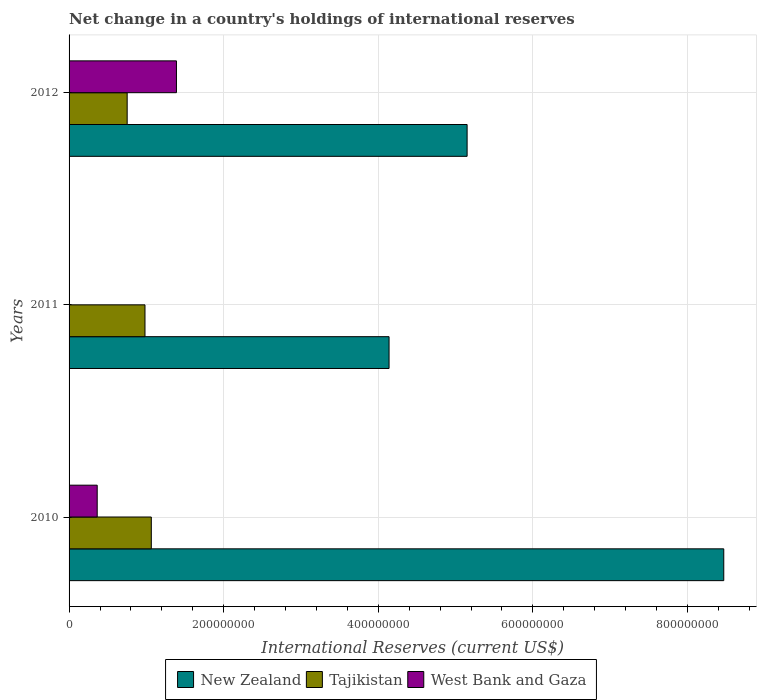How many different coloured bars are there?
Provide a short and direct response. 3. How many groups of bars are there?
Provide a short and direct response. 3. Are the number of bars on each tick of the Y-axis equal?
Give a very brief answer. No. What is the label of the 3rd group of bars from the top?
Your answer should be very brief. 2010. What is the international reserves in West Bank and Gaza in 2010?
Your answer should be very brief. 3.64e+07. Across all years, what is the maximum international reserves in New Zealand?
Offer a terse response. 8.47e+08. Across all years, what is the minimum international reserves in New Zealand?
Provide a succinct answer. 4.14e+08. In which year was the international reserves in West Bank and Gaza maximum?
Ensure brevity in your answer.  2012. What is the total international reserves in Tajikistan in the graph?
Your answer should be compact. 2.80e+08. What is the difference between the international reserves in New Zealand in 2011 and that in 2012?
Keep it short and to the point. -1.01e+08. What is the difference between the international reserves in New Zealand in 2010 and the international reserves in West Bank and Gaza in 2012?
Keep it short and to the point. 7.08e+08. What is the average international reserves in Tajikistan per year?
Offer a terse response. 9.32e+07. In the year 2012, what is the difference between the international reserves in West Bank and Gaza and international reserves in New Zealand?
Provide a succinct answer. -3.76e+08. What is the ratio of the international reserves in West Bank and Gaza in 2010 to that in 2012?
Your response must be concise. 0.26. Is the difference between the international reserves in West Bank and Gaza in 2010 and 2012 greater than the difference between the international reserves in New Zealand in 2010 and 2012?
Make the answer very short. No. What is the difference between the highest and the second highest international reserves in Tajikistan?
Provide a short and direct response. 8.18e+06. What is the difference between the highest and the lowest international reserves in Tajikistan?
Give a very brief answer. 3.12e+07. In how many years, is the international reserves in Tajikistan greater than the average international reserves in Tajikistan taken over all years?
Offer a very short reply. 2. Is the sum of the international reserves in Tajikistan in 2011 and 2012 greater than the maximum international reserves in New Zealand across all years?
Provide a short and direct response. No. Is it the case that in every year, the sum of the international reserves in New Zealand and international reserves in West Bank and Gaza is greater than the international reserves in Tajikistan?
Provide a succinct answer. Yes. Are all the bars in the graph horizontal?
Ensure brevity in your answer.  Yes. How many years are there in the graph?
Ensure brevity in your answer.  3. What is the difference between two consecutive major ticks on the X-axis?
Offer a terse response. 2.00e+08. Where does the legend appear in the graph?
Give a very brief answer. Bottom center. How many legend labels are there?
Your answer should be very brief. 3. How are the legend labels stacked?
Offer a terse response. Horizontal. What is the title of the graph?
Your response must be concise. Net change in a country's holdings of international reserves. What is the label or title of the X-axis?
Your response must be concise. International Reserves (current US$). What is the International Reserves (current US$) of New Zealand in 2010?
Keep it short and to the point. 8.47e+08. What is the International Reserves (current US$) of Tajikistan in 2010?
Offer a very short reply. 1.06e+08. What is the International Reserves (current US$) in West Bank and Gaza in 2010?
Your response must be concise. 3.64e+07. What is the International Reserves (current US$) in New Zealand in 2011?
Give a very brief answer. 4.14e+08. What is the International Reserves (current US$) of Tajikistan in 2011?
Keep it short and to the point. 9.82e+07. What is the International Reserves (current US$) in New Zealand in 2012?
Your answer should be compact. 5.15e+08. What is the International Reserves (current US$) of Tajikistan in 2012?
Provide a short and direct response. 7.52e+07. What is the International Reserves (current US$) in West Bank and Gaza in 2012?
Provide a short and direct response. 1.39e+08. Across all years, what is the maximum International Reserves (current US$) of New Zealand?
Provide a short and direct response. 8.47e+08. Across all years, what is the maximum International Reserves (current US$) of Tajikistan?
Your answer should be very brief. 1.06e+08. Across all years, what is the maximum International Reserves (current US$) in West Bank and Gaza?
Offer a terse response. 1.39e+08. Across all years, what is the minimum International Reserves (current US$) in New Zealand?
Give a very brief answer. 4.14e+08. Across all years, what is the minimum International Reserves (current US$) in Tajikistan?
Ensure brevity in your answer.  7.52e+07. Across all years, what is the minimum International Reserves (current US$) of West Bank and Gaza?
Your response must be concise. 0. What is the total International Reserves (current US$) of New Zealand in the graph?
Make the answer very short. 1.78e+09. What is the total International Reserves (current US$) in Tajikistan in the graph?
Offer a very short reply. 2.80e+08. What is the total International Reserves (current US$) in West Bank and Gaza in the graph?
Provide a short and direct response. 1.75e+08. What is the difference between the International Reserves (current US$) in New Zealand in 2010 and that in 2011?
Your response must be concise. 4.33e+08. What is the difference between the International Reserves (current US$) of Tajikistan in 2010 and that in 2011?
Make the answer very short. 8.18e+06. What is the difference between the International Reserves (current US$) in New Zealand in 2010 and that in 2012?
Make the answer very short. 3.32e+08. What is the difference between the International Reserves (current US$) of Tajikistan in 2010 and that in 2012?
Your answer should be compact. 3.12e+07. What is the difference between the International Reserves (current US$) in West Bank and Gaza in 2010 and that in 2012?
Your answer should be very brief. -1.02e+08. What is the difference between the International Reserves (current US$) in New Zealand in 2011 and that in 2012?
Provide a succinct answer. -1.01e+08. What is the difference between the International Reserves (current US$) in Tajikistan in 2011 and that in 2012?
Your answer should be compact. 2.30e+07. What is the difference between the International Reserves (current US$) of New Zealand in 2010 and the International Reserves (current US$) of Tajikistan in 2011?
Keep it short and to the point. 7.49e+08. What is the difference between the International Reserves (current US$) in New Zealand in 2010 and the International Reserves (current US$) in Tajikistan in 2012?
Provide a short and direct response. 7.72e+08. What is the difference between the International Reserves (current US$) of New Zealand in 2010 and the International Reserves (current US$) of West Bank and Gaza in 2012?
Provide a succinct answer. 7.08e+08. What is the difference between the International Reserves (current US$) of Tajikistan in 2010 and the International Reserves (current US$) of West Bank and Gaza in 2012?
Offer a terse response. -3.25e+07. What is the difference between the International Reserves (current US$) in New Zealand in 2011 and the International Reserves (current US$) in Tajikistan in 2012?
Offer a very short reply. 3.39e+08. What is the difference between the International Reserves (current US$) of New Zealand in 2011 and the International Reserves (current US$) of West Bank and Gaza in 2012?
Your response must be concise. 2.75e+08. What is the difference between the International Reserves (current US$) of Tajikistan in 2011 and the International Reserves (current US$) of West Bank and Gaza in 2012?
Your answer should be very brief. -4.07e+07. What is the average International Reserves (current US$) in New Zealand per year?
Your answer should be very brief. 5.92e+08. What is the average International Reserves (current US$) in Tajikistan per year?
Your response must be concise. 9.32e+07. What is the average International Reserves (current US$) of West Bank and Gaza per year?
Keep it short and to the point. 5.84e+07. In the year 2010, what is the difference between the International Reserves (current US$) of New Zealand and International Reserves (current US$) of Tajikistan?
Offer a terse response. 7.41e+08. In the year 2010, what is the difference between the International Reserves (current US$) in New Zealand and International Reserves (current US$) in West Bank and Gaza?
Ensure brevity in your answer.  8.10e+08. In the year 2010, what is the difference between the International Reserves (current US$) of Tajikistan and International Reserves (current US$) of West Bank and Gaza?
Offer a very short reply. 7.00e+07. In the year 2011, what is the difference between the International Reserves (current US$) in New Zealand and International Reserves (current US$) in Tajikistan?
Offer a terse response. 3.16e+08. In the year 2012, what is the difference between the International Reserves (current US$) of New Zealand and International Reserves (current US$) of Tajikistan?
Give a very brief answer. 4.40e+08. In the year 2012, what is the difference between the International Reserves (current US$) in New Zealand and International Reserves (current US$) in West Bank and Gaza?
Offer a very short reply. 3.76e+08. In the year 2012, what is the difference between the International Reserves (current US$) of Tajikistan and International Reserves (current US$) of West Bank and Gaza?
Your answer should be compact. -6.37e+07. What is the ratio of the International Reserves (current US$) of New Zealand in 2010 to that in 2011?
Keep it short and to the point. 2.05. What is the ratio of the International Reserves (current US$) in Tajikistan in 2010 to that in 2011?
Offer a terse response. 1.08. What is the ratio of the International Reserves (current US$) in New Zealand in 2010 to that in 2012?
Provide a short and direct response. 1.64. What is the ratio of the International Reserves (current US$) of Tajikistan in 2010 to that in 2012?
Your response must be concise. 1.42. What is the ratio of the International Reserves (current US$) of West Bank and Gaza in 2010 to that in 2012?
Offer a very short reply. 0.26. What is the ratio of the International Reserves (current US$) in New Zealand in 2011 to that in 2012?
Your response must be concise. 0.8. What is the ratio of the International Reserves (current US$) in Tajikistan in 2011 to that in 2012?
Keep it short and to the point. 1.31. What is the difference between the highest and the second highest International Reserves (current US$) of New Zealand?
Your answer should be very brief. 3.32e+08. What is the difference between the highest and the second highest International Reserves (current US$) in Tajikistan?
Offer a terse response. 8.18e+06. What is the difference between the highest and the lowest International Reserves (current US$) of New Zealand?
Give a very brief answer. 4.33e+08. What is the difference between the highest and the lowest International Reserves (current US$) of Tajikistan?
Offer a very short reply. 3.12e+07. What is the difference between the highest and the lowest International Reserves (current US$) in West Bank and Gaza?
Offer a terse response. 1.39e+08. 